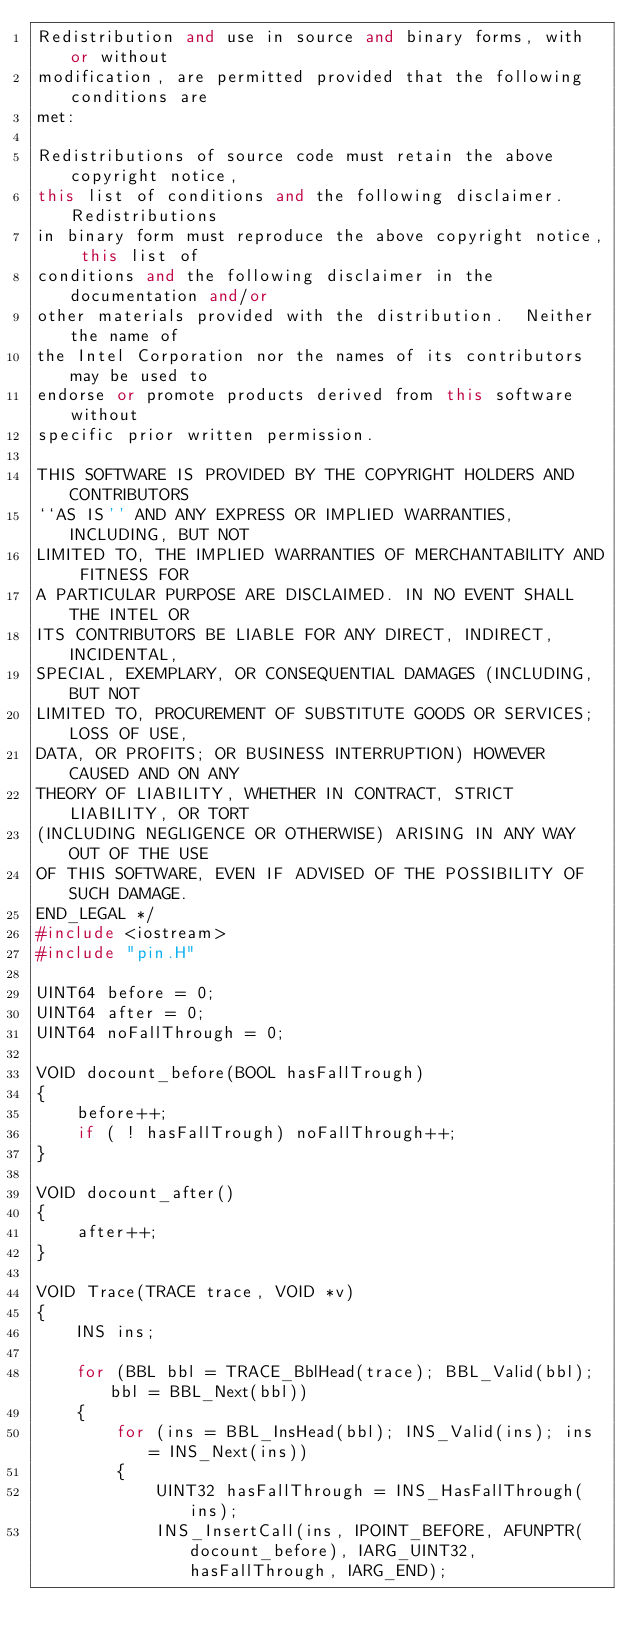Convert code to text. <code><loc_0><loc_0><loc_500><loc_500><_C++_>Redistribution and use in source and binary forms, with or without
modification, are permitted provided that the following conditions are
met:

Redistributions of source code must retain the above copyright notice,
this list of conditions and the following disclaimer.  Redistributions
in binary form must reproduce the above copyright notice, this list of
conditions and the following disclaimer in the documentation and/or
other materials provided with the distribution.  Neither the name of
the Intel Corporation nor the names of its contributors may be used to
endorse or promote products derived from this software without
specific prior written permission.
 
THIS SOFTWARE IS PROVIDED BY THE COPYRIGHT HOLDERS AND CONTRIBUTORS
``AS IS'' AND ANY EXPRESS OR IMPLIED WARRANTIES, INCLUDING, BUT NOT
LIMITED TO, THE IMPLIED WARRANTIES OF MERCHANTABILITY AND FITNESS FOR
A PARTICULAR PURPOSE ARE DISCLAIMED. IN NO EVENT SHALL THE INTEL OR
ITS CONTRIBUTORS BE LIABLE FOR ANY DIRECT, INDIRECT, INCIDENTAL,
SPECIAL, EXEMPLARY, OR CONSEQUENTIAL DAMAGES (INCLUDING, BUT NOT
LIMITED TO, PROCUREMENT OF SUBSTITUTE GOODS OR SERVICES; LOSS OF USE,
DATA, OR PROFITS; OR BUSINESS INTERRUPTION) HOWEVER CAUSED AND ON ANY
THEORY OF LIABILITY, WHETHER IN CONTRACT, STRICT LIABILITY, OR TORT
(INCLUDING NEGLIGENCE OR OTHERWISE) ARISING IN ANY WAY OUT OF THE USE
OF THIS SOFTWARE, EVEN IF ADVISED OF THE POSSIBILITY OF SUCH DAMAGE.
END_LEGAL */
#include <iostream>
#include "pin.H"

UINT64 before = 0;
UINT64 after = 0;
UINT64 noFallThrough = 0;

VOID docount_before(BOOL hasFallTrough)
{
    before++;
    if ( ! hasFallTrough) noFallThrough++;
}

VOID docount_after()
{
    after++;
}

VOID Trace(TRACE trace, VOID *v)
{
    INS ins;
    
    for (BBL bbl = TRACE_BblHead(trace); BBL_Valid(bbl); bbl = BBL_Next(bbl))
    {
        for (ins = BBL_InsHead(bbl); INS_Valid(ins); ins = INS_Next(ins))
        {
            UINT32 hasFallThrough = INS_HasFallThrough(ins);
            INS_InsertCall(ins, IPOINT_BEFORE, AFUNPTR(docount_before), IARG_UINT32, hasFallThrough, IARG_END);</code> 